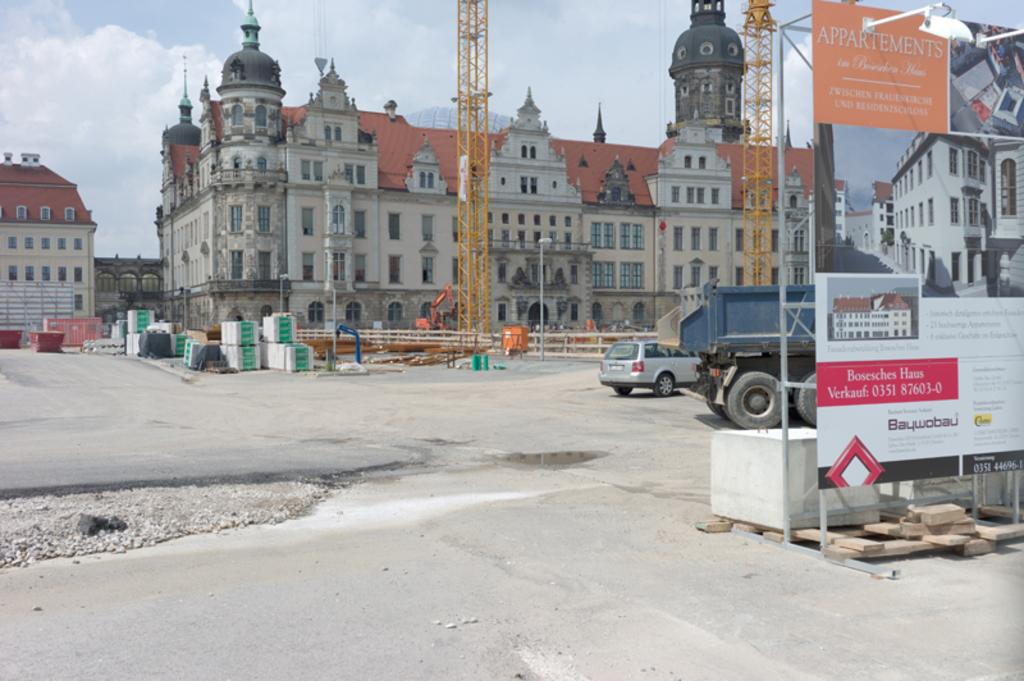What type of structures can be seen in the image? There are buildings and towers in the image. What are some other objects present in the image? There are poles, a fence, a hoarding, vehicles, and other objects in the image. What is the nature of the transportation visible in the image? There are vehicles in the image, which suggests the presence of transportation. What is the condition of the sky in the image? The sky is visible in the background of the image, and there are clouds in the sky. What type of company is depicted on the hoarding in the image? There is no company mentioned or depicted on the hoarding in the image. Are there any bushes visible in the image? There is no mention of bushes in the provided facts, and therefore it cannot be determined if they are present in the image. What type of breakfast is being served in the image? There is no reference to breakfast or any food items in the image. 